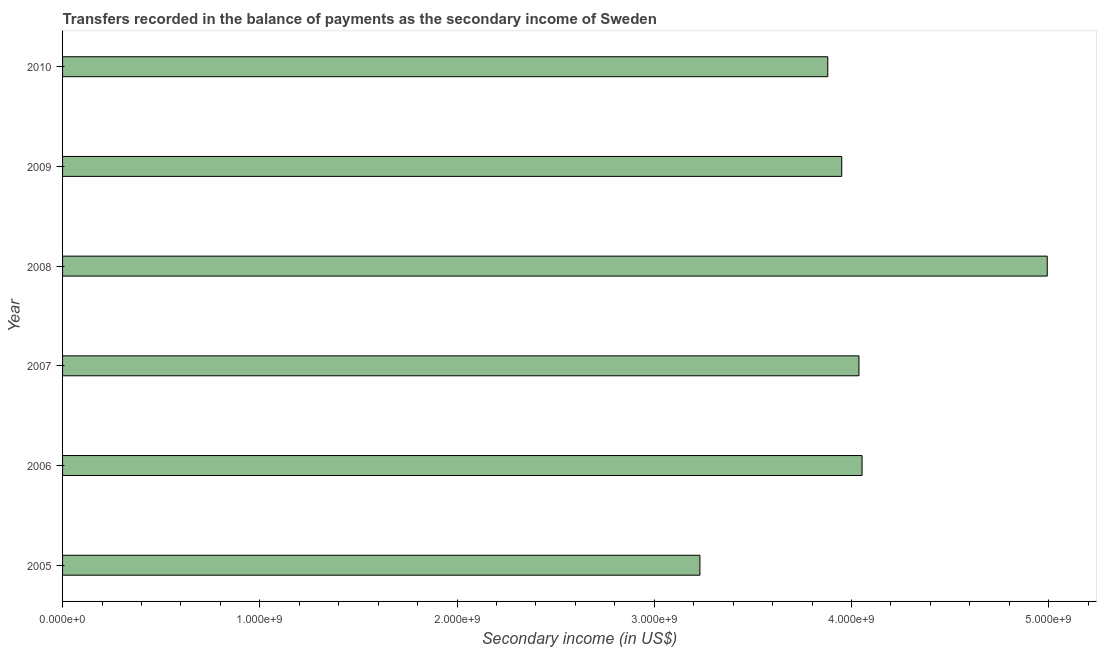Does the graph contain any zero values?
Offer a very short reply. No. What is the title of the graph?
Offer a very short reply. Transfers recorded in the balance of payments as the secondary income of Sweden. What is the label or title of the X-axis?
Offer a very short reply. Secondary income (in US$). What is the amount of secondary income in 2007?
Offer a very short reply. 4.04e+09. Across all years, what is the maximum amount of secondary income?
Offer a terse response. 4.99e+09. Across all years, what is the minimum amount of secondary income?
Make the answer very short. 3.23e+09. In which year was the amount of secondary income minimum?
Your answer should be compact. 2005. What is the sum of the amount of secondary income?
Your answer should be very brief. 2.41e+1. What is the difference between the amount of secondary income in 2007 and 2010?
Offer a very short reply. 1.58e+08. What is the average amount of secondary income per year?
Your answer should be compact. 4.02e+09. What is the median amount of secondary income?
Offer a very short reply. 3.99e+09. In how many years, is the amount of secondary income greater than 2000000000 US$?
Offer a terse response. 6. Do a majority of the years between 2008 and 2007 (inclusive) have amount of secondary income greater than 2600000000 US$?
Your answer should be very brief. No. What is the ratio of the amount of secondary income in 2005 to that in 2008?
Your answer should be very brief. 0.65. Is the difference between the amount of secondary income in 2005 and 2006 greater than the difference between any two years?
Keep it short and to the point. No. What is the difference between the highest and the second highest amount of secondary income?
Your answer should be very brief. 9.39e+08. Is the sum of the amount of secondary income in 2005 and 2006 greater than the maximum amount of secondary income across all years?
Your answer should be very brief. Yes. What is the difference between the highest and the lowest amount of secondary income?
Your response must be concise. 1.76e+09. Are all the bars in the graph horizontal?
Your answer should be compact. Yes. How many years are there in the graph?
Your answer should be very brief. 6. What is the Secondary income (in US$) of 2005?
Offer a terse response. 3.23e+09. What is the Secondary income (in US$) of 2006?
Make the answer very short. 4.05e+09. What is the Secondary income (in US$) of 2007?
Offer a very short reply. 4.04e+09. What is the Secondary income (in US$) in 2008?
Offer a very short reply. 4.99e+09. What is the Secondary income (in US$) of 2009?
Your answer should be very brief. 3.95e+09. What is the Secondary income (in US$) in 2010?
Give a very brief answer. 3.88e+09. What is the difference between the Secondary income (in US$) in 2005 and 2006?
Keep it short and to the point. -8.22e+08. What is the difference between the Secondary income (in US$) in 2005 and 2007?
Provide a succinct answer. -8.06e+08. What is the difference between the Secondary income (in US$) in 2005 and 2008?
Offer a terse response. -1.76e+09. What is the difference between the Secondary income (in US$) in 2005 and 2009?
Offer a very short reply. -7.19e+08. What is the difference between the Secondary income (in US$) in 2005 and 2010?
Give a very brief answer. -6.48e+08. What is the difference between the Secondary income (in US$) in 2006 and 2007?
Offer a terse response. 1.58e+07. What is the difference between the Secondary income (in US$) in 2006 and 2008?
Your answer should be compact. -9.39e+08. What is the difference between the Secondary income (in US$) in 2006 and 2009?
Provide a succinct answer. 1.03e+08. What is the difference between the Secondary income (in US$) in 2006 and 2010?
Your answer should be very brief. 1.74e+08. What is the difference between the Secondary income (in US$) in 2007 and 2008?
Your answer should be very brief. -9.55e+08. What is the difference between the Secondary income (in US$) in 2007 and 2009?
Your answer should be compact. 8.74e+07. What is the difference between the Secondary income (in US$) in 2007 and 2010?
Make the answer very short. 1.58e+08. What is the difference between the Secondary income (in US$) in 2008 and 2009?
Ensure brevity in your answer.  1.04e+09. What is the difference between the Secondary income (in US$) in 2008 and 2010?
Provide a short and direct response. 1.11e+09. What is the difference between the Secondary income (in US$) in 2009 and 2010?
Keep it short and to the point. 7.08e+07. What is the ratio of the Secondary income (in US$) in 2005 to that in 2006?
Offer a very short reply. 0.8. What is the ratio of the Secondary income (in US$) in 2005 to that in 2007?
Give a very brief answer. 0.8. What is the ratio of the Secondary income (in US$) in 2005 to that in 2008?
Ensure brevity in your answer.  0.65. What is the ratio of the Secondary income (in US$) in 2005 to that in 2009?
Give a very brief answer. 0.82. What is the ratio of the Secondary income (in US$) in 2005 to that in 2010?
Keep it short and to the point. 0.83. What is the ratio of the Secondary income (in US$) in 2006 to that in 2007?
Your answer should be very brief. 1. What is the ratio of the Secondary income (in US$) in 2006 to that in 2008?
Offer a very short reply. 0.81. What is the ratio of the Secondary income (in US$) in 2006 to that in 2009?
Your answer should be very brief. 1.03. What is the ratio of the Secondary income (in US$) in 2006 to that in 2010?
Offer a terse response. 1.04. What is the ratio of the Secondary income (in US$) in 2007 to that in 2008?
Offer a terse response. 0.81. What is the ratio of the Secondary income (in US$) in 2007 to that in 2010?
Provide a succinct answer. 1.04. What is the ratio of the Secondary income (in US$) in 2008 to that in 2009?
Your answer should be compact. 1.26. What is the ratio of the Secondary income (in US$) in 2008 to that in 2010?
Offer a very short reply. 1.29. What is the ratio of the Secondary income (in US$) in 2009 to that in 2010?
Ensure brevity in your answer.  1.02. 